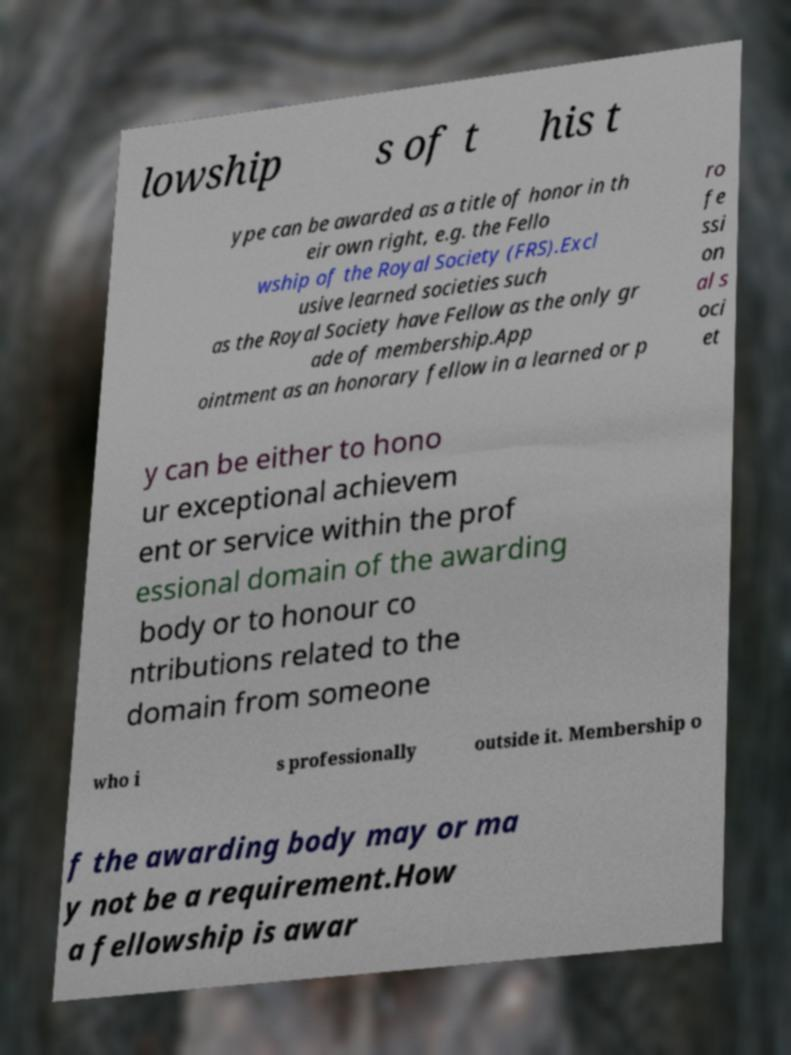There's text embedded in this image that I need extracted. Can you transcribe it verbatim? lowship s of t his t ype can be awarded as a title of honor in th eir own right, e.g. the Fello wship of the Royal Society (FRS).Excl usive learned societies such as the Royal Society have Fellow as the only gr ade of membership.App ointment as an honorary fellow in a learned or p ro fe ssi on al s oci et y can be either to hono ur exceptional achievem ent or service within the prof essional domain of the awarding body or to honour co ntributions related to the domain from someone who i s professionally outside it. Membership o f the awarding body may or ma y not be a requirement.How a fellowship is awar 